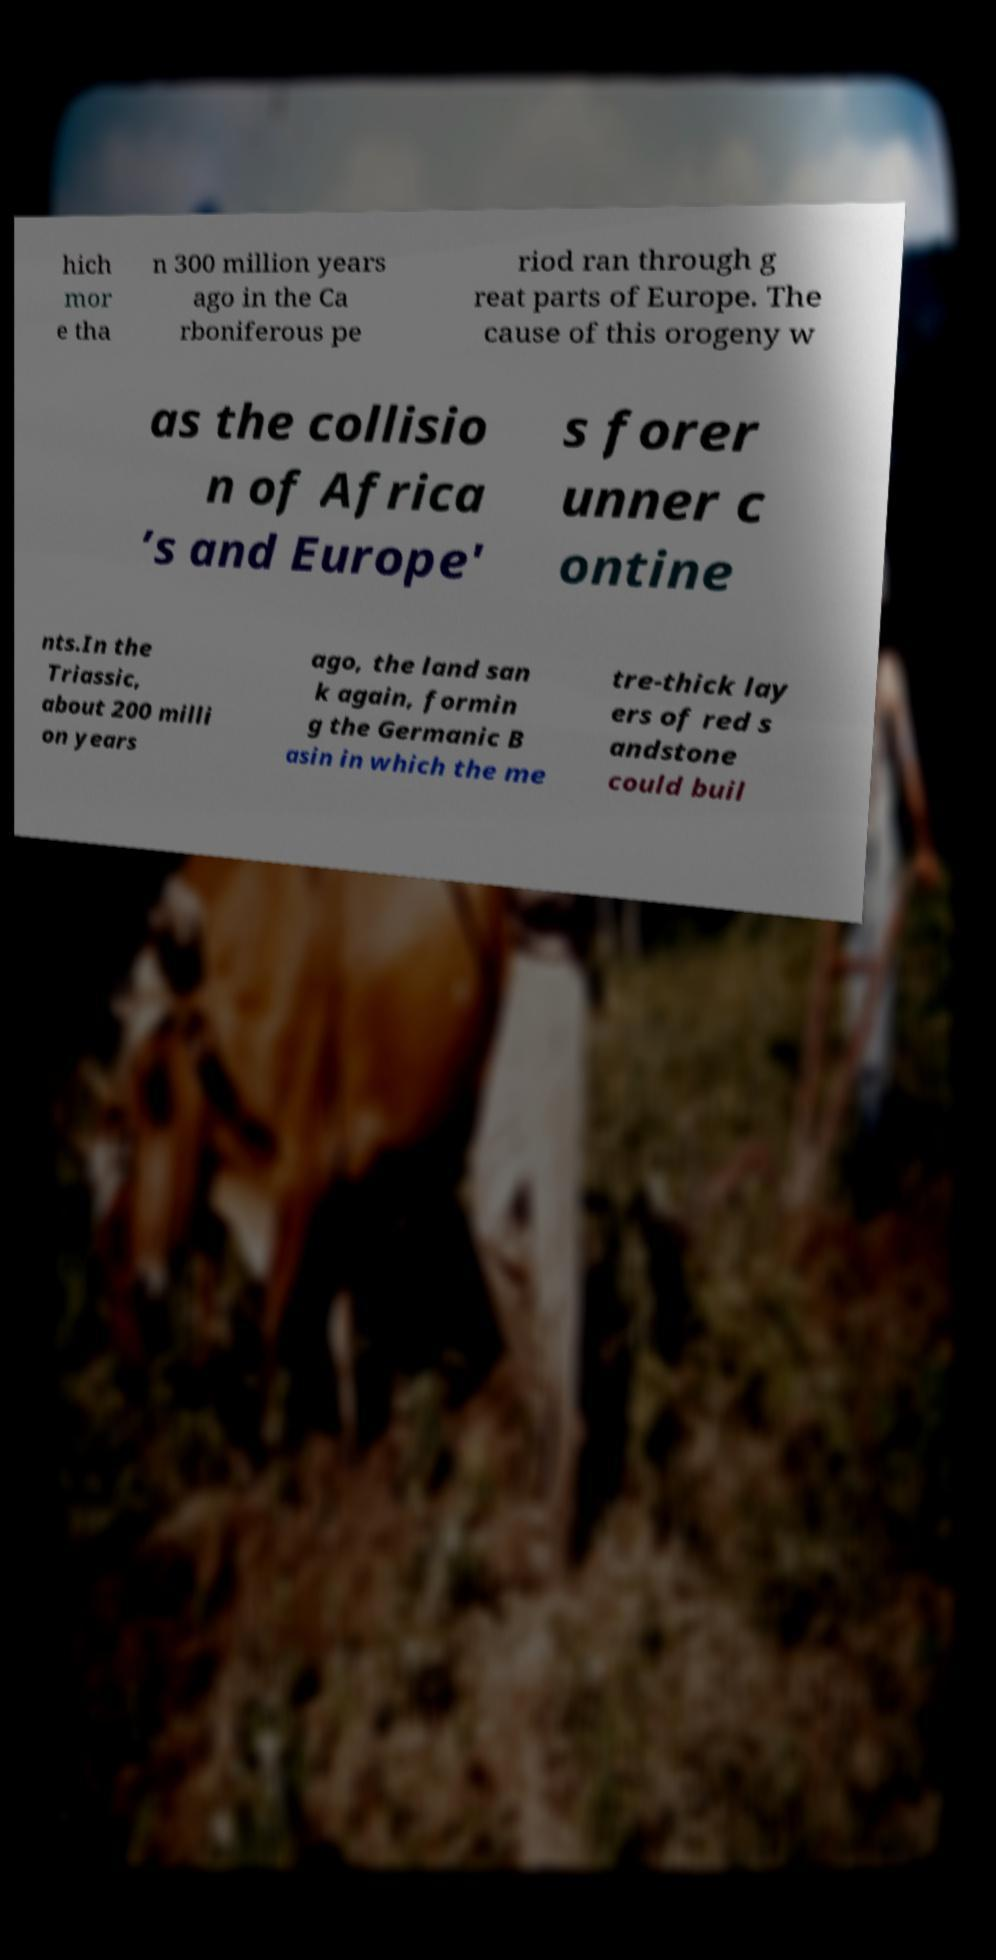Please read and relay the text visible in this image. What does it say? hich mor e tha n 300 million years ago in the Ca rboniferous pe riod ran through g reat parts of Europe. The cause of this orogeny w as the collisio n of Africa ’s and Europe' s forer unner c ontine nts.In the Triassic, about 200 milli on years ago, the land san k again, formin g the Germanic B asin in which the me tre-thick lay ers of red s andstone could buil 